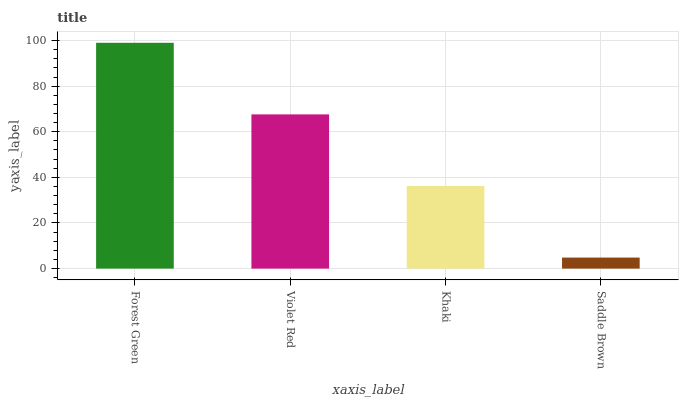Is Saddle Brown the minimum?
Answer yes or no. Yes. Is Forest Green the maximum?
Answer yes or no. Yes. Is Violet Red the minimum?
Answer yes or no. No. Is Violet Red the maximum?
Answer yes or no. No. Is Forest Green greater than Violet Red?
Answer yes or no. Yes. Is Violet Red less than Forest Green?
Answer yes or no. Yes. Is Violet Red greater than Forest Green?
Answer yes or no. No. Is Forest Green less than Violet Red?
Answer yes or no. No. Is Violet Red the high median?
Answer yes or no. Yes. Is Khaki the low median?
Answer yes or no. Yes. Is Forest Green the high median?
Answer yes or no. No. Is Saddle Brown the low median?
Answer yes or no. No. 